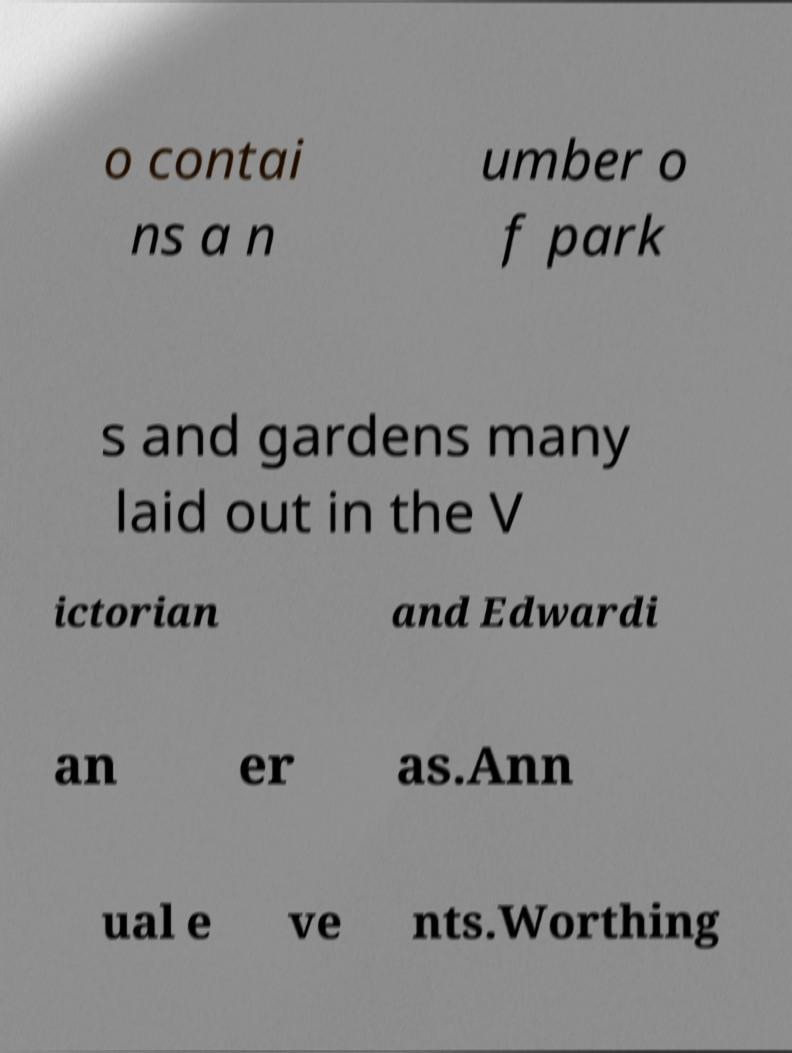I need the written content from this picture converted into text. Can you do that? o contai ns a n umber o f park s and gardens many laid out in the V ictorian and Edwardi an er as.Ann ual e ve nts.Worthing 